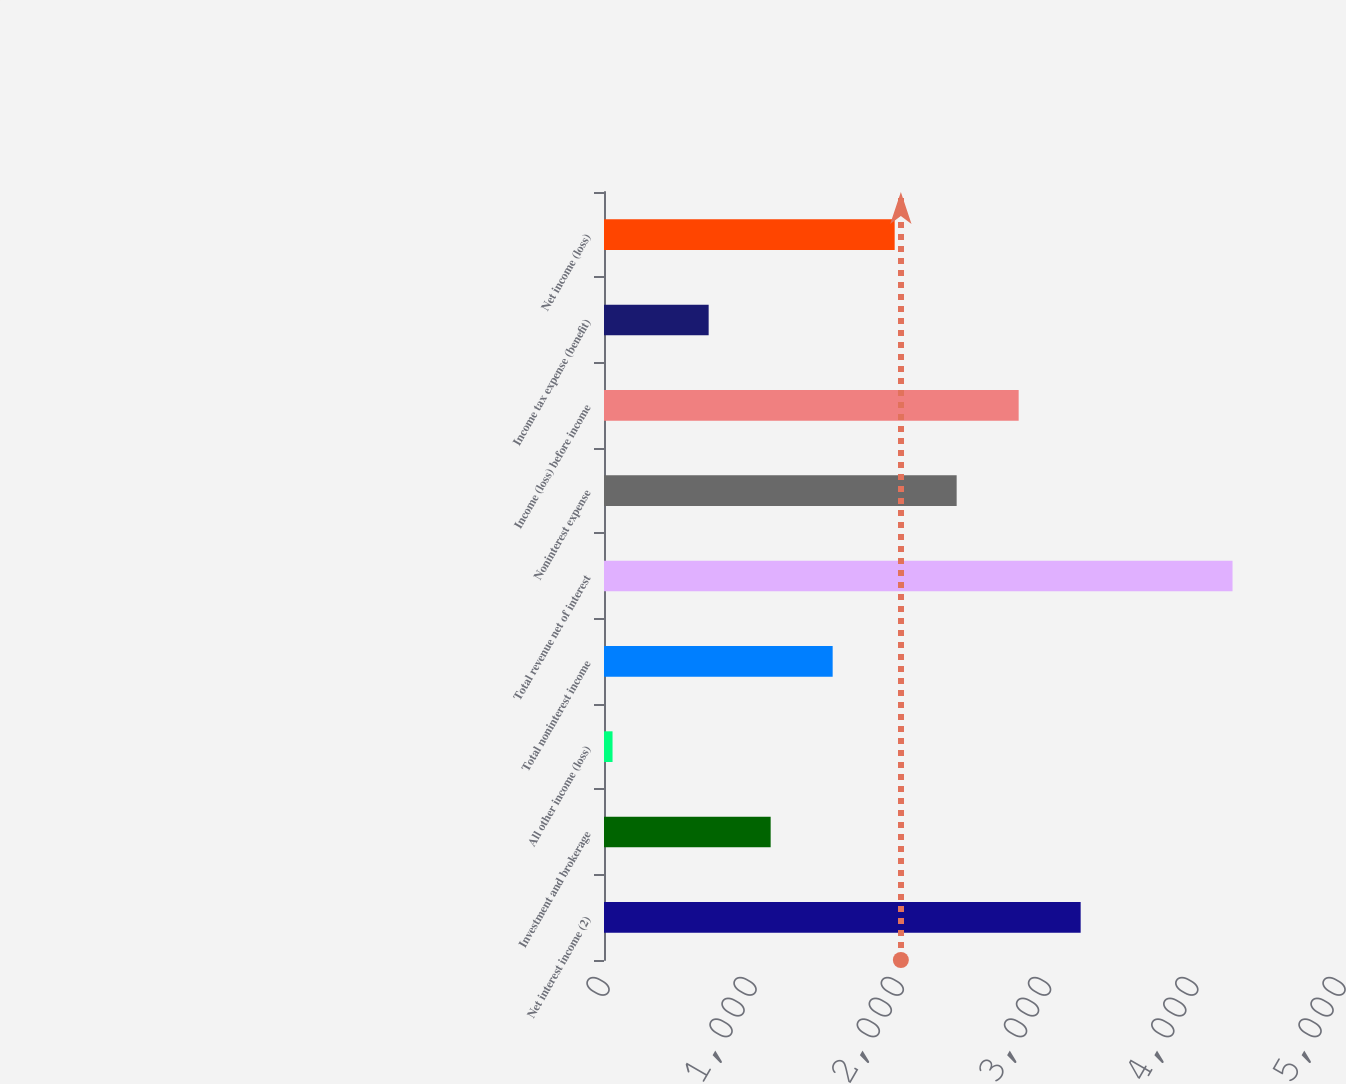Convert chart to OTSL. <chart><loc_0><loc_0><loc_500><loc_500><bar_chart><fcel>Net interest income (2)<fcel>Investment and brokerage<fcel>All other income (loss)<fcel>Total noninterest income<fcel>Total revenue net of interest<fcel>Noninterest expense<fcel>Income (loss) before income<fcel>Income tax expense (benefit)<fcel>Net income (loss)<nl><fcel>3238.2<fcel>1132.2<fcel>58<fcel>1553.4<fcel>4270<fcel>2395.8<fcel>2817<fcel>711<fcel>1974.6<nl></chart> 